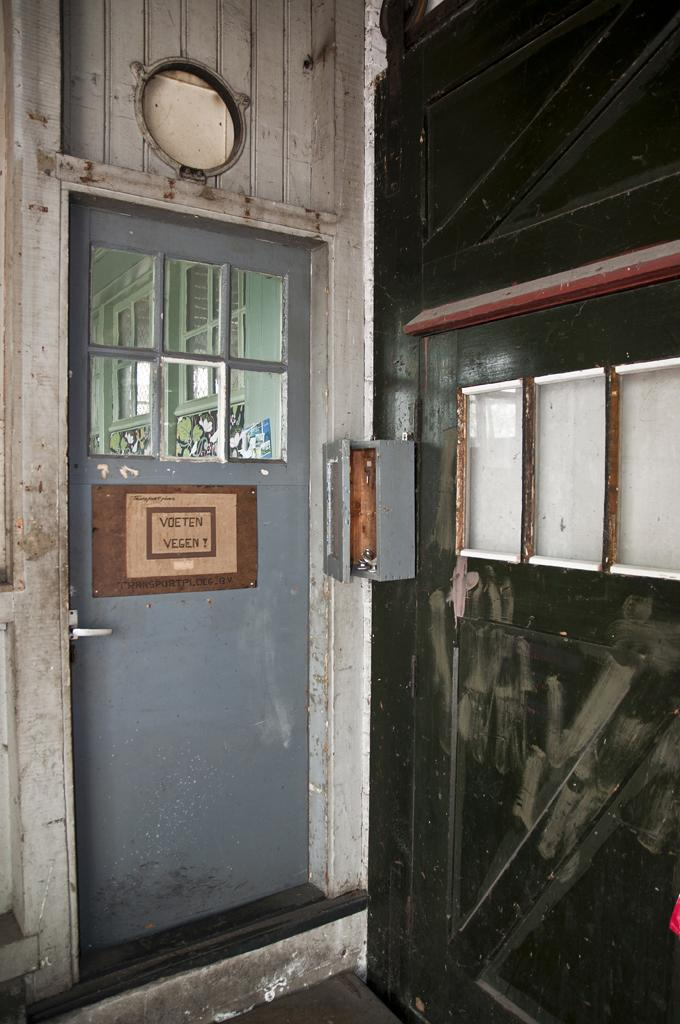What type of door is on the left side of the image? There is a door with glass on the left side of the image. What is located in the middle of the image? There is a box in the middle of the image. What is the frame on the right side of the image made of? The frame on the right side of the image is made of white color and has glass. How much wealth is displayed in the image? There is no indication of wealth in the image; it features a door with glass, a box, and a white color frame with glass. Can you tell me which airport is visible in the image? There is no airport present in the image. 